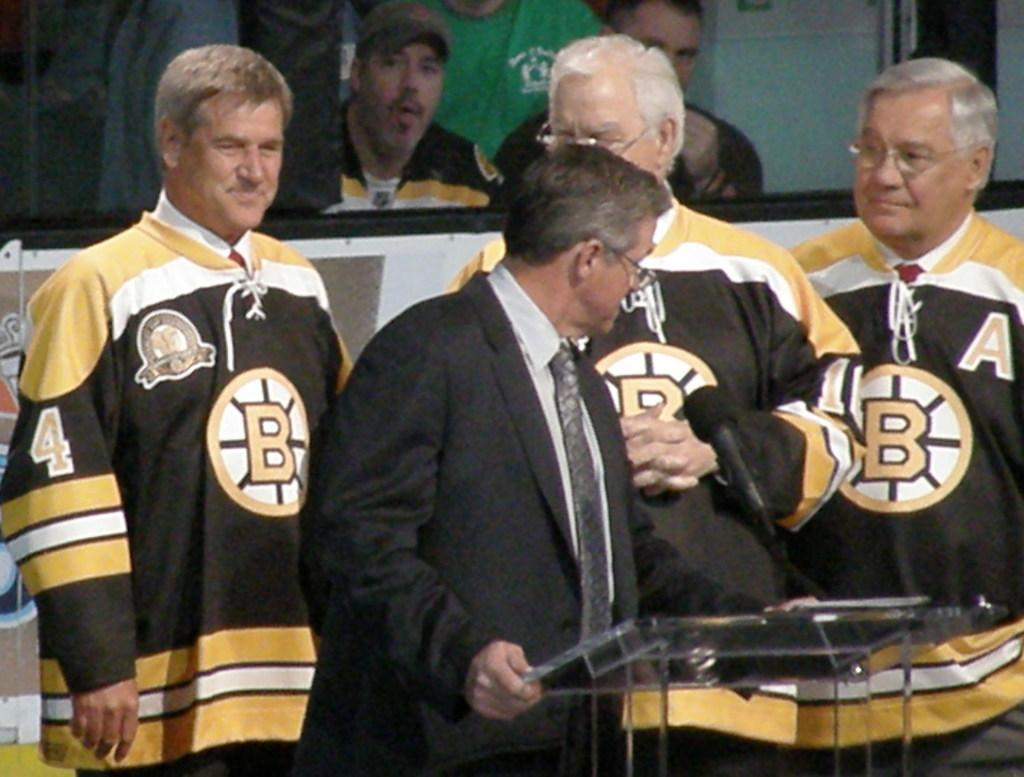<image>
Render a clear and concise summary of the photo. A man is standing at a podium in from of three men wearing jerseys with the letter B on them. 